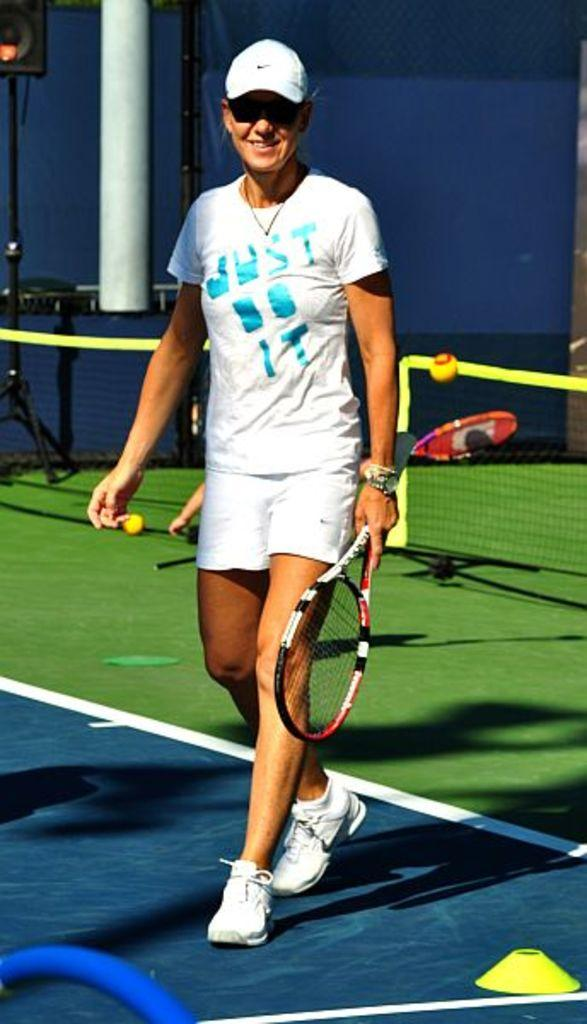Who or what is present in the image? There is a person in the image. What is the person holding in the image? The person is holding a racket. What else can be seen in the image besides the person and the racket? There is a net and a ball in the image. What type of cart is being used by the person in the image? There is no cart present in the image. 